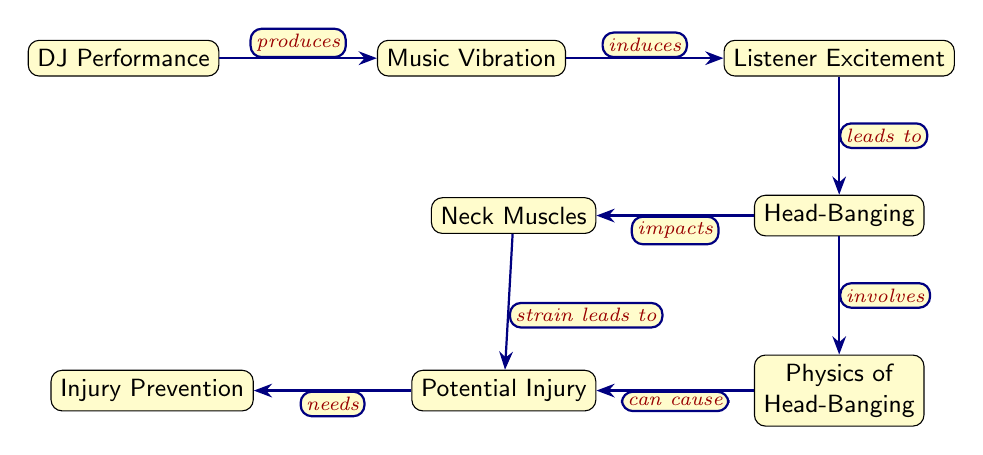What is the first node in the diagram? The first node is "DJ Performance," which is the starting point of the flow in the diagram representing the relationship between the DJ and the subsequent concepts.
Answer: DJ Performance How many edges are present in the diagram? There are a total of 7 edges connecting the nodes, illustrating the relationships between the concepts related to head-banging and its effects.
Answer: 7 What does "Listener Excitement" lead to? "Listener Excitement" directly leads to "Head-Banging," indicating that increased excitement from music leads to physical reactions such as head-banging.
Answer: Head-Banging Which node involves physics? The node that involves physics is "Physics of Head-Banging," indicating that the dynamics of head-banging are considered in this part of the diagram.
Answer: Physics of Head-Banging What can "Potential Injury" cause? "Potential Injury" can cause "Injury Prevention," which suggests that the potential for injury necessitates measures to avoid injuries related to head-banging.
Answer: Injury Prevention What impacts neck muscles? "Head-Banging" impacts "Neck Muscles," indicating that the action of head-banging has a direct effect on the muscles in the neck.
Answer: Neck Muscles Which node is located below "Head-Banging"? The node located below "Head-Banging" is "Physics of Head-Banging," indicating a relationship regarding the mechanics involved in head-banging.
Answer: Physics of Head-Banging What does neck muscle strain lead to? Neck muscle strain leads to "Potential Injury," indicating that straining the neck muscles through head-banging can result in injurious outcomes.
Answer: Potential Injury 